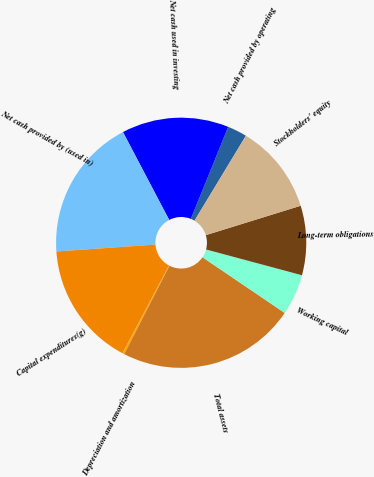Convert chart. <chart><loc_0><loc_0><loc_500><loc_500><pie_chart><fcel>Net cash provided by operating<fcel>Net cash used in investing<fcel>Net cash provided by (used in)<fcel>Capital expenditures(g)<fcel>Depreciation and amortization<fcel>Total assets<fcel>Working capital<fcel>Long-term obligations<fcel>Stockholders' equity<nl><fcel>2.52%<fcel>13.84%<fcel>18.4%<fcel>16.12%<fcel>0.25%<fcel>23.04%<fcel>5.3%<fcel>8.96%<fcel>11.56%<nl></chart> 